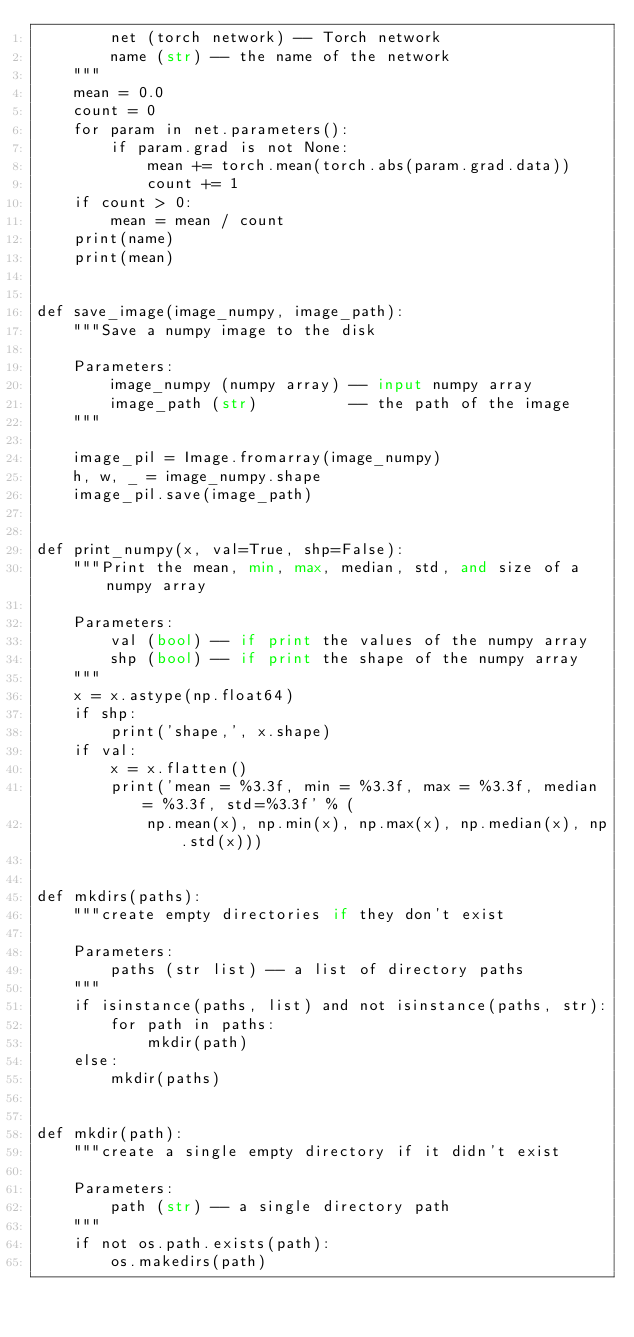Convert code to text. <code><loc_0><loc_0><loc_500><loc_500><_Python_>        net (torch network) -- Torch network
        name (str) -- the name of the network
    """
    mean = 0.0
    count = 0
    for param in net.parameters():
        if param.grad is not None:
            mean += torch.mean(torch.abs(param.grad.data))
            count += 1
    if count > 0:
        mean = mean / count
    print(name)
    print(mean)


def save_image(image_numpy, image_path):
    """Save a numpy image to the disk

    Parameters:
        image_numpy (numpy array) -- input numpy array
        image_path (str)          -- the path of the image
    """

    image_pil = Image.fromarray(image_numpy)
    h, w, _ = image_numpy.shape
    image_pil.save(image_path)


def print_numpy(x, val=True, shp=False):
    """Print the mean, min, max, median, std, and size of a numpy array

    Parameters:
        val (bool) -- if print the values of the numpy array
        shp (bool) -- if print the shape of the numpy array
    """
    x = x.astype(np.float64)
    if shp:
        print('shape,', x.shape)
    if val:
        x = x.flatten()
        print('mean = %3.3f, min = %3.3f, max = %3.3f, median = %3.3f, std=%3.3f' % (
            np.mean(x), np.min(x), np.max(x), np.median(x), np.std(x)))


def mkdirs(paths):
    """create empty directories if they don't exist

    Parameters:
        paths (str list) -- a list of directory paths
    """
    if isinstance(paths, list) and not isinstance(paths, str):
        for path in paths:
            mkdir(path)
    else:
        mkdir(paths)


def mkdir(path):
    """create a single empty directory if it didn't exist

    Parameters:
        path (str) -- a single directory path
    """
    if not os.path.exists(path):
        os.makedirs(path)
</code> 